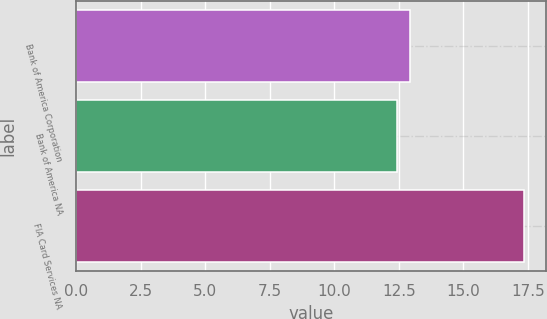Convert chart. <chart><loc_0><loc_0><loc_500><loc_500><bar_chart><fcel>Bank of America Corporation<fcel>Bank of America NA<fcel>FIA Card Services NA<nl><fcel>12.93<fcel>12.44<fcel>17.34<nl></chart> 